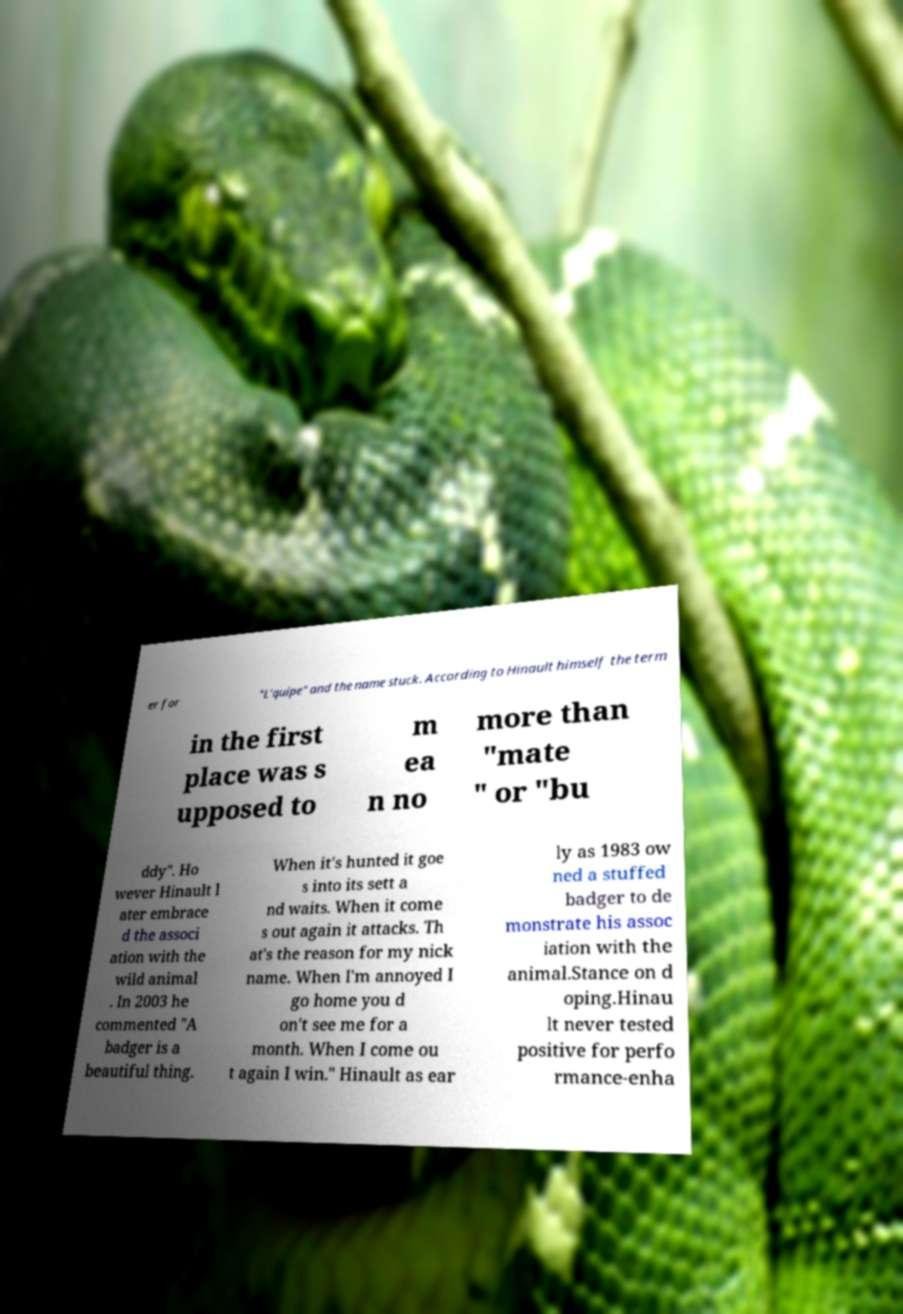Can you accurately transcribe the text from the provided image for me? er for "L'quipe" and the name stuck. According to Hinault himself the term in the first place was s upposed to m ea n no more than "mate " or "bu ddy". Ho wever Hinault l ater embrace d the associ ation with the wild animal . In 2003 he commented "A badger is a beautiful thing. When it's hunted it goe s into its sett a nd waits. When it come s out again it attacks. Th at's the reason for my nick name. When I'm annoyed I go home you d on't see me for a month. When I come ou t again I win." Hinault as ear ly as 1983 ow ned a stuffed badger to de monstrate his assoc iation with the animal.Stance on d oping.Hinau lt never tested positive for perfo rmance-enha 